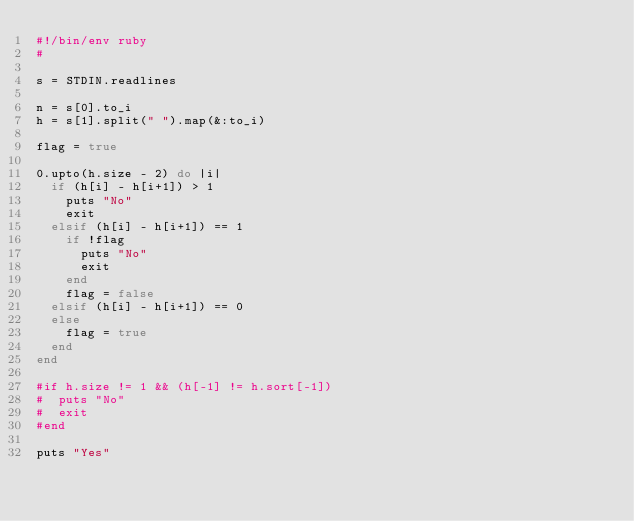<code> <loc_0><loc_0><loc_500><loc_500><_Ruby_>#!/bin/env ruby
#

s = STDIN.readlines

n = s[0].to_i
h = s[1].split(" ").map(&:to_i)

flag = true

0.upto(h.size - 2) do |i|
  if (h[i] - h[i+1]) > 1
    puts "No"
    exit
  elsif (h[i] - h[i+1]) == 1
    if !flag
      puts "No"
      exit
    end
    flag = false
  elsif (h[i] - h[i+1]) == 0
  else
    flag = true
  end
end

#if h.size != 1 && (h[-1] != h.sort[-1])
#  puts "No"
#  exit
#end

puts "Yes"
</code> 